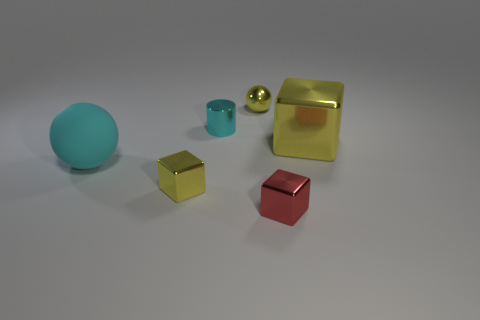Is there anything else that has the same shape as the cyan metal object?
Your answer should be very brief. No. There is a yellow shiny object that is both on the left side of the tiny red metallic object and behind the big cyan rubber thing; what size is it?
Offer a terse response. Small. Are there any other things that are the same color as the small shiny cylinder?
Your answer should be compact. Yes. What shape is the tiny cyan object that is made of the same material as the tiny red object?
Make the answer very short. Cylinder. There is a red shiny thing; does it have the same shape as the thing to the right of the tiny red metal cube?
Offer a terse response. Yes. What is the material of the small yellow thing on the left side of the small yellow thing that is behind the big block?
Provide a succinct answer. Metal. Is the number of big cyan rubber things that are behind the yellow metallic ball the same as the number of big cyan things?
Offer a very short reply. No. Is there anything else that has the same material as the cyan sphere?
Your answer should be very brief. No. Is the color of the sphere on the left side of the cyan metal thing the same as the tiny shiny cylinder that is behind the small red metallic cube?
Your answer should be compact. Yes. How many yellow things are in front of the tiny cyan metal object and behind the large matte sphere?
Give a very brief answer. 1. 